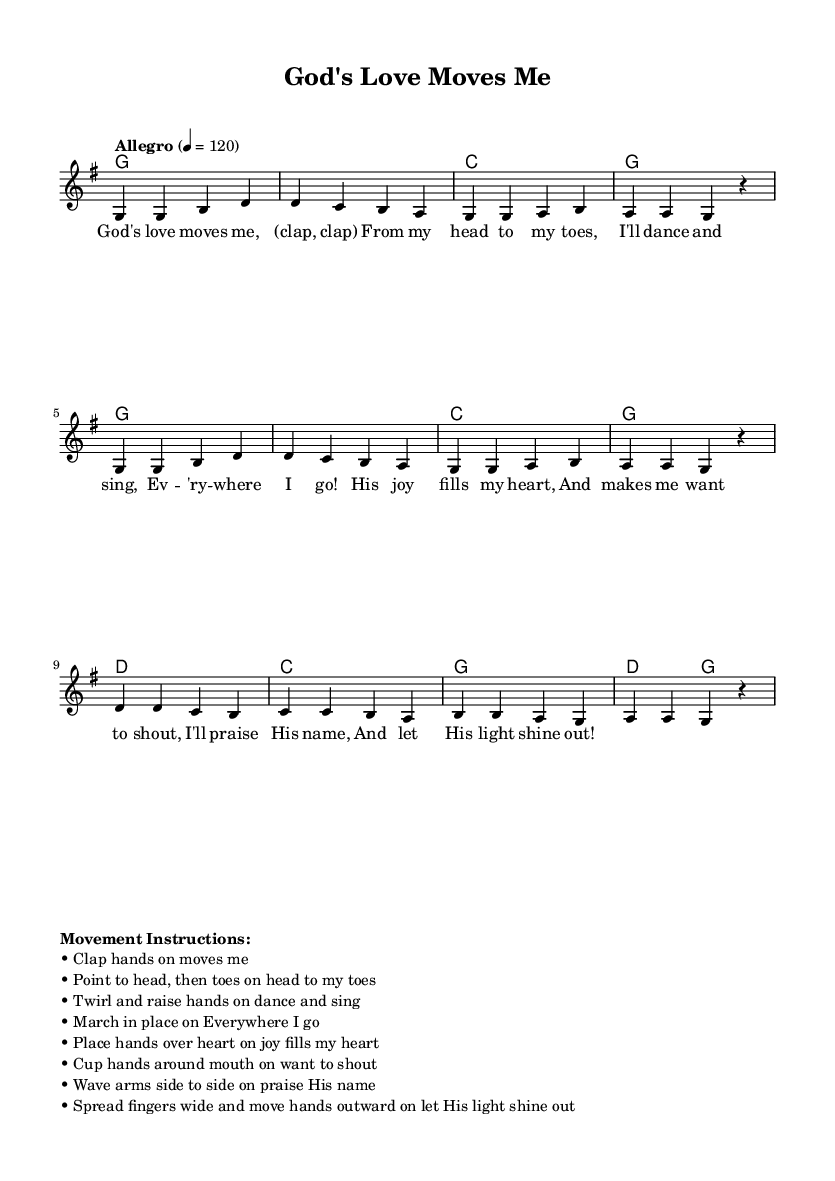What is the key signature of this music? The key signature is G major, which has one sharp (F#).
Answer: G major What is the time signature of this music? The time signature shown in the music is 4/4, meaning there are four beats in a measure.
Answer: 4/4 What is the tempo marking for this song? The tempo marking indicates "Allegro," which means to play fast and lively.
Answer: Allegro How many measures are in the melody section? The melody section contains eight measures as indicated by the divisions in the music.
Answer: Eight What is the first lyric of the song? The first lyric is "God's love moves me," as shown in the lyrics section of the music.
Answer: God's love moves me What movement is suggested when the lyrics say "From my head to my toes"? The instruction suggests pointing to the head and then to the toes.
Answer: Point to head, then toes What action should be taken on the phrase "let His light shine out"? The instruction for this phrase is to spread fingers wide and move hands outward.
Answer: Spread fingers wide and move hands outward 